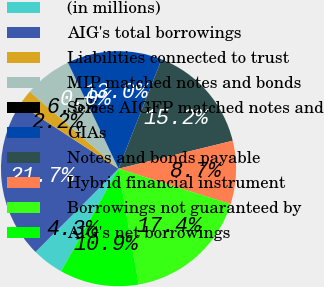Convert chart to OTSL. <chart><loc_0><loc_0><loc_500><loc_500><pie_chart><fcel>(in millions)<fcel>AIG's total borrowings<fcel>Liabilities connected to trust<fcel>MIP matched notes and bonds<fcel>Series AIGFP matched notes and<fcel>GIAs<fcel>Notes and bonds payable<fcel>Hybrid financial instrument<fcel>Borrowings not guaranteed by<fcel>AIG's net borrowings<nl><fcel>4.35%<fcel>21.73%<fcel>2.18%<fcel>6.53%<fcel>0.01%<fcel>13.04%<fcel>15.21%<fcel>8.7%<fcel>17.38%<fcel>10.87%<nl></chart> 